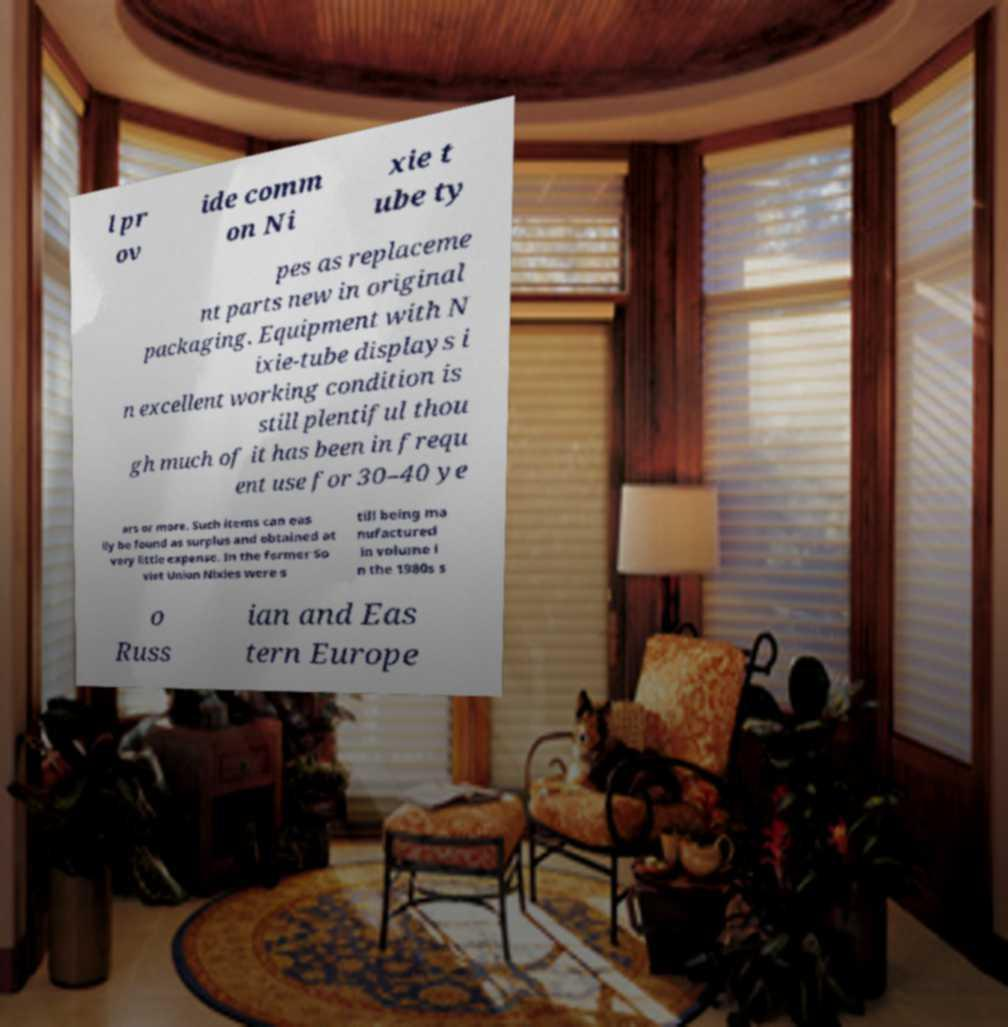Could you assist in decoding the text presented in this image and type it out clearly? l pr ov ide comm on Ni xie t ube ty pes as replaceme nt parts new in original packaging. Equipment with N ixie-tube displays i n excellent working condition is still plentiful thou gh much of it has been in frequ ent use for 30–40 ye ars or more. Such items can eas ily be found as surplus and obtained at very little expense. In the former So viet Union Nixies were s till being ma nufactured in volume i n the 1980s s o Russ ian and Eas tern Europe 